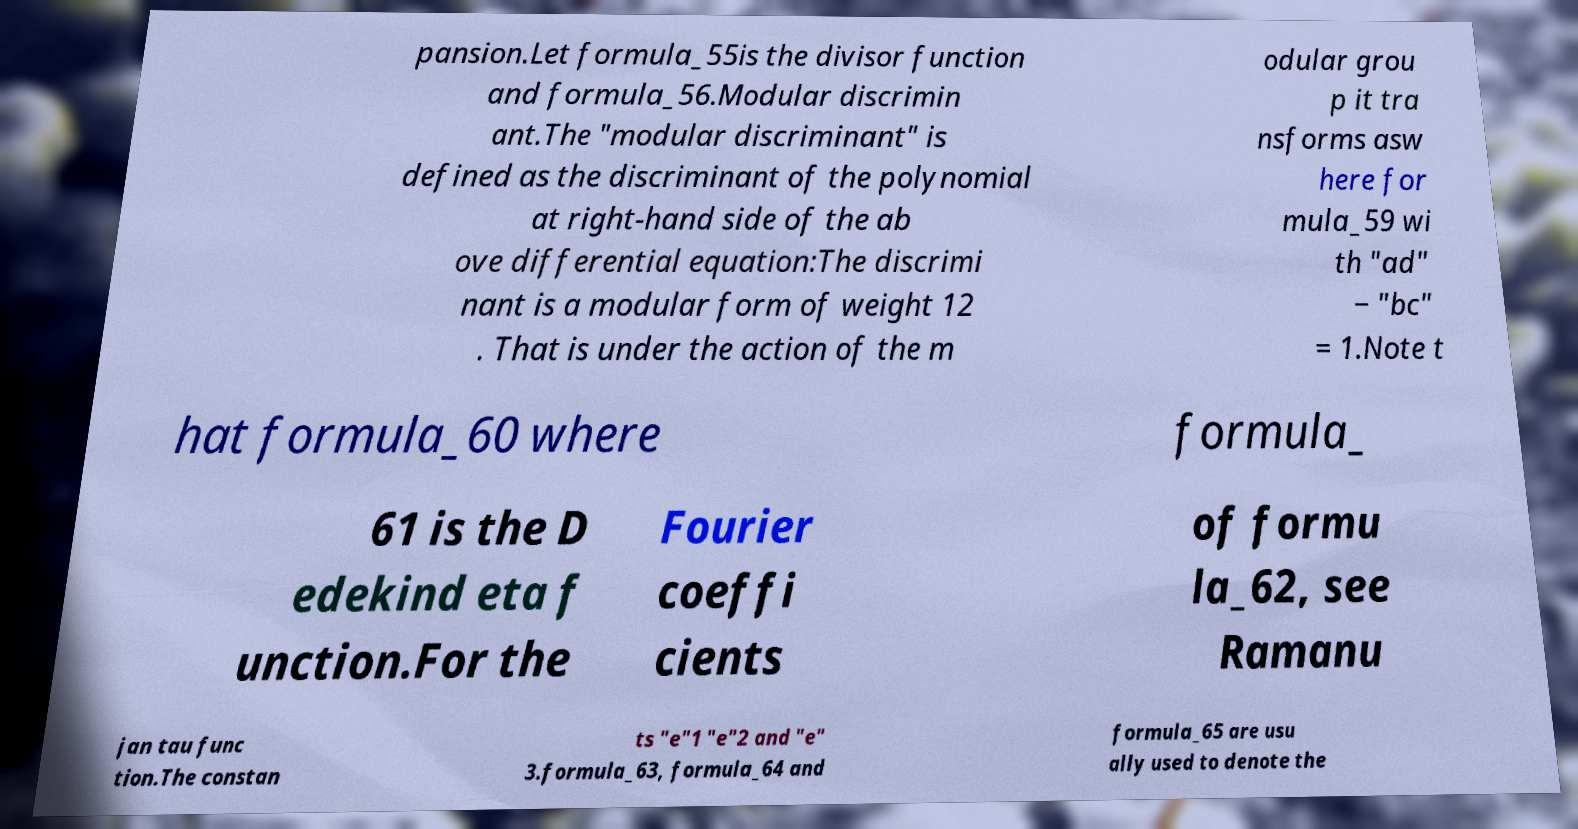Please identify and transcribe the text found in this image. pansion.Let formula_55is the divisor function and formula_56.Modular discrimin ant.The "modular discriminant" is defined as the discriminant of the polynomial at right-hand side of the ab ove differential equation:The discrimi nant is a modular form of weight 12 . That is under the action of the m odular grou p it tra nsforms asw here for mula_59 wi th "ad" − "bc" = 1.Note t hat formula_60 where formula_ 61 is the D edekind eta f unction.For the Fourier coeffi cients of formu la_62, see Ramanu jan tau func tion.The constan ts "e"1 "e"2 and "e" 3.formula_63, formula_64 and formula_65 are usu ally used to denote the 